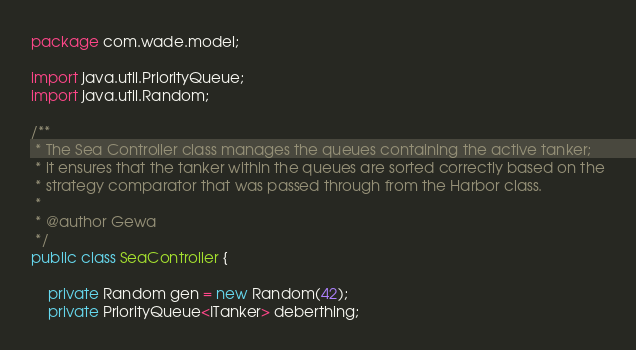<code> <loc_0><loc_0><loc_500><loc_500><_Java_>
package com.wade.model;

import java.util.PriorityQueue;
import java.util.Random;

/**
 * The Sea Controller class manages the queues containing the active tanker;
 * it ensures that the tanker within the queues are sorted correctly based on the
 * strategy comparator that was passed through from the Harbor class.
 * 
 * @author Gewa
 */
public class SeaController {
    
    private Random gen = new Random(42);
    private PriorityQueue<ITanker> deberthing;</code> 